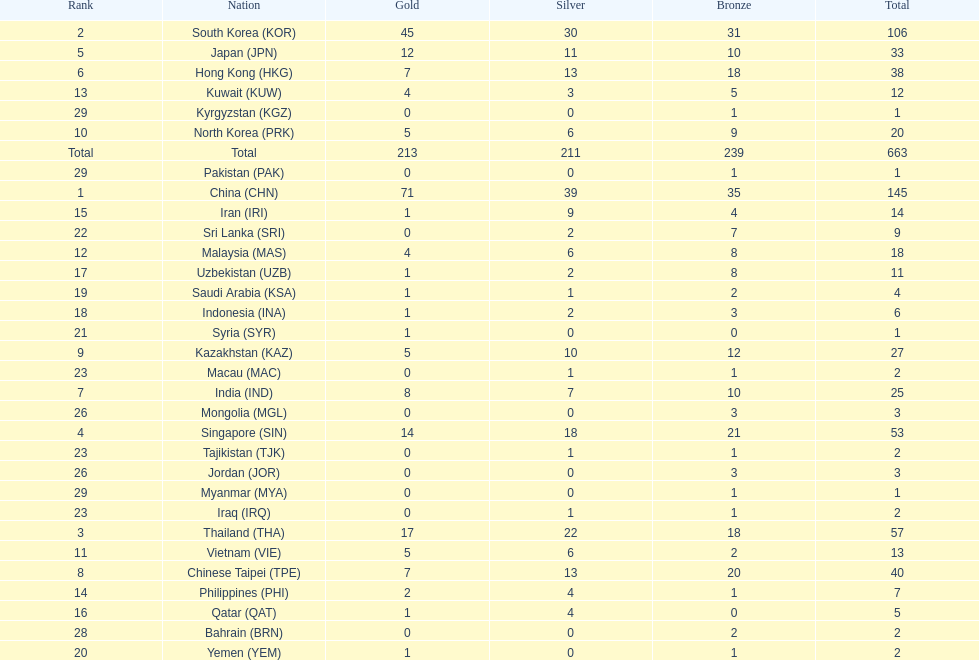Which countries have the same number of silver medals in the asian youth games as north korea? Vietnam (VIE), Malaysia (MAS). 